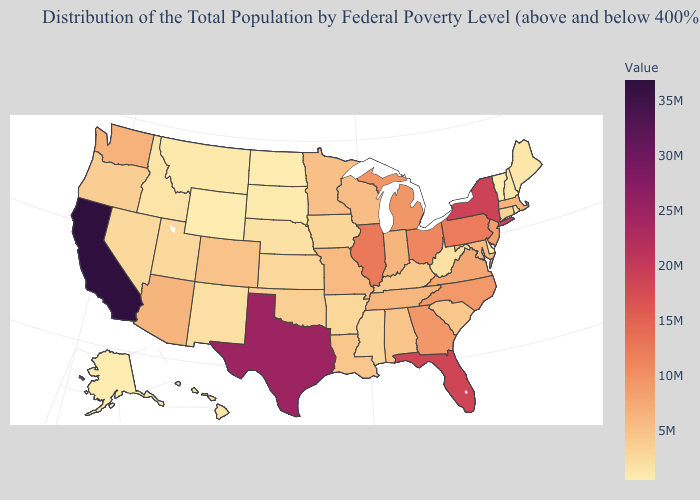Which states have the lowest value in the USA?
Concise answer only. Wyoming. Does California have the highest value in the USA?
Write a very short answer. Yes. Does the map have missing data?
Answer briefly. No. Does Georgia have a lower value than Texas?
Be succinct. Yes. Which states have the lowest value in the MidWest?
Short answer required. North Dakota. Is the legend a continuous bar?
Concise answer only. Yes. 